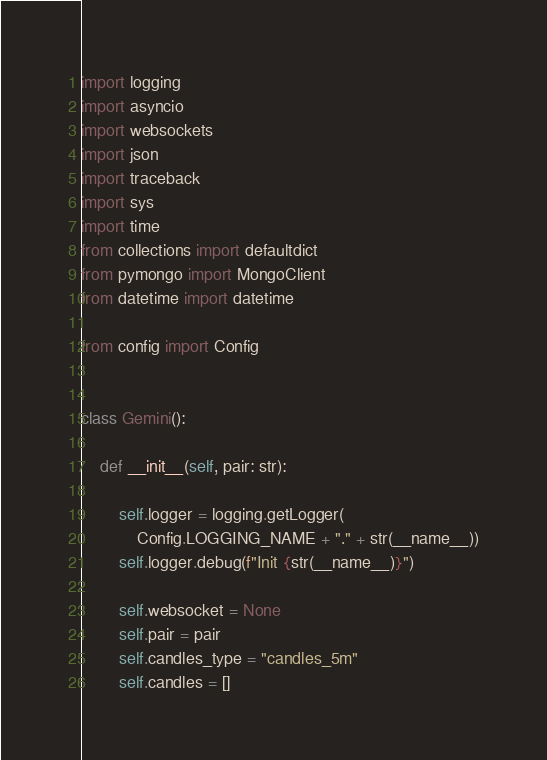<code> <loc_0><loc_0><loc_500><loc_500><_Python_>import logging
import asyncio
import websockets
import json
import traceback
import sys
import time
from collections import defaultdict
from pymongo import MongoClient
from datetime import datetime

from config import Config


class Gemini():

    def __init__(self, pair: str):

        self.logger = logging.getLogger(
            Config.LOGGING_NAME + "." + str(__name__))
        self.logger.debug(f"Init {str(__name__)}")

        self.websocket = None
        self.pair = pair
        self.candles_type = "candles_5m"
        self.candles = []
</code> 